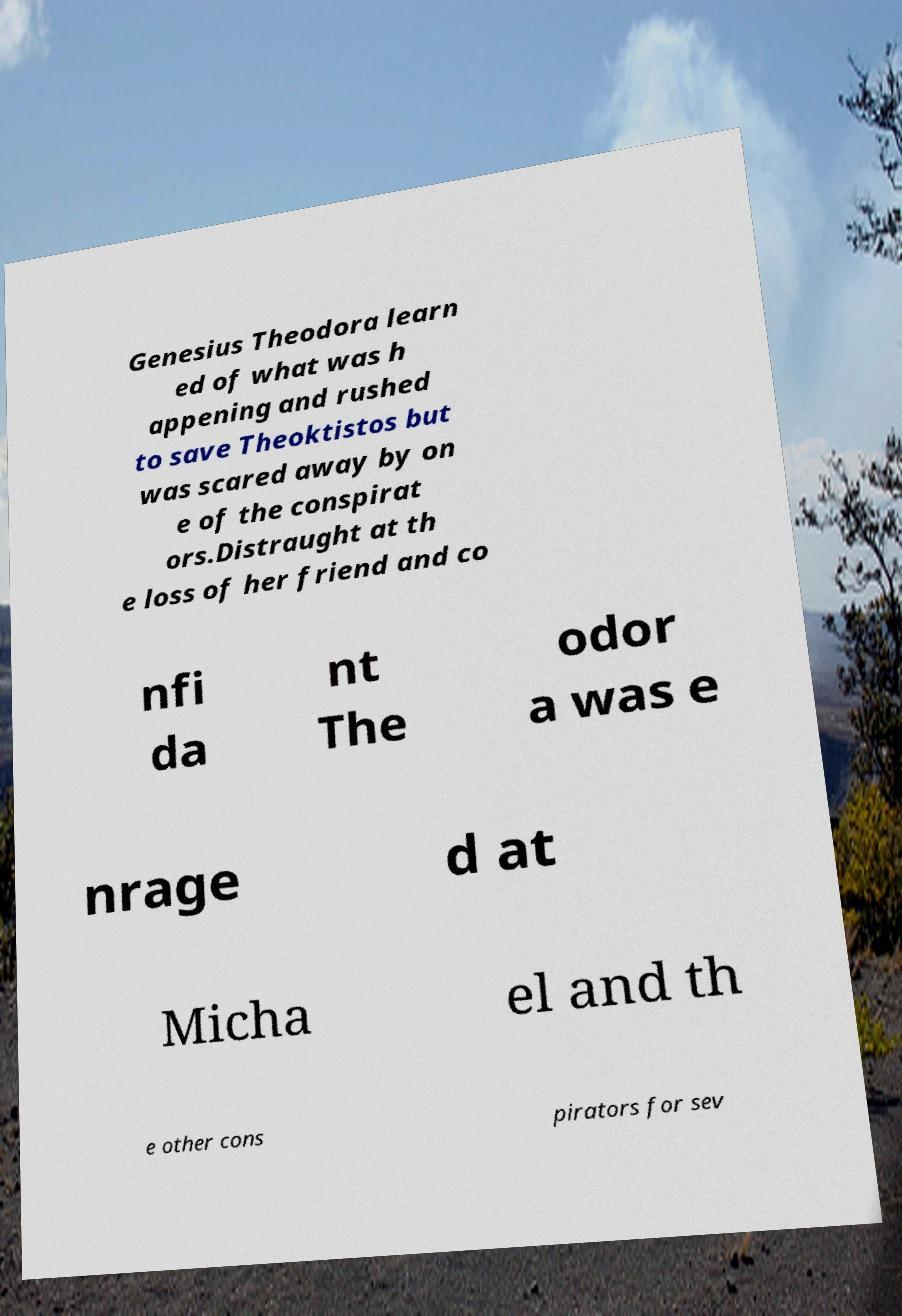Can you accurately transcribe the text from the provided image for me? Genesius Theodora learn ed of what was h appening and rushed to save Theoktistos but was scared away by on e of the conspirat ors.Distraught at th e loss of her friend and co nfi da nt The odor a was e nrage d at Micha el and th e other cons pirators for sev 